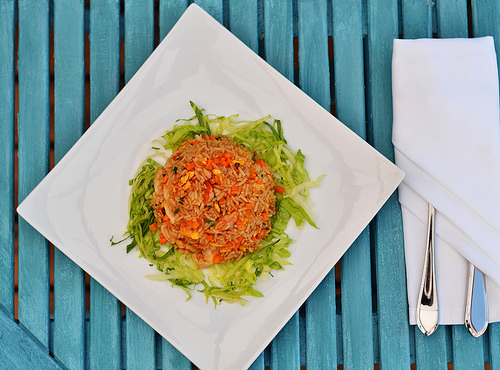<image>
Is the rice on the lettuce? Yes. Looking at the image, I can see the rice is positioned on top of the lettuce, with the lettuce providing support. Is the silverware next to the rice? Yes. The silverware is positioned adjacent to the rice, located nearby in the same general area. 